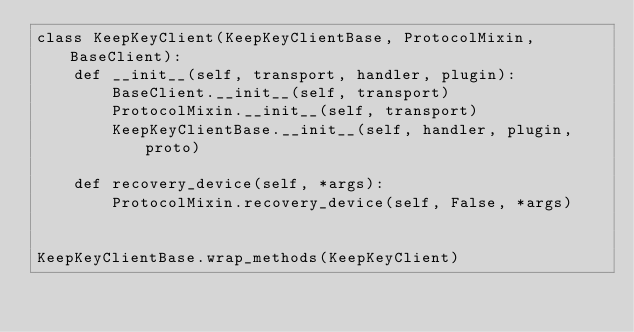<code> <loc_0><loc_0><loc_500><loc_500><_Python_>class KeepKeyClient(KeepKeyClientBase, ProtocolMixin, BaseClient):
    def __init__(self, transport, handler, plugin):
        BaseClient.__init__(self, transport)
        ProtocolMixin.__init__(self, transport)
        KeepKeyClientBase.__init__(self, handler, plugin, proto)

    def recovery_device(self, *args):
        ProtocolMixin.recovery_device(self, False, *args)


KeepKeyClientBase.wrap_methods(KeepKeyClient)
</code> 